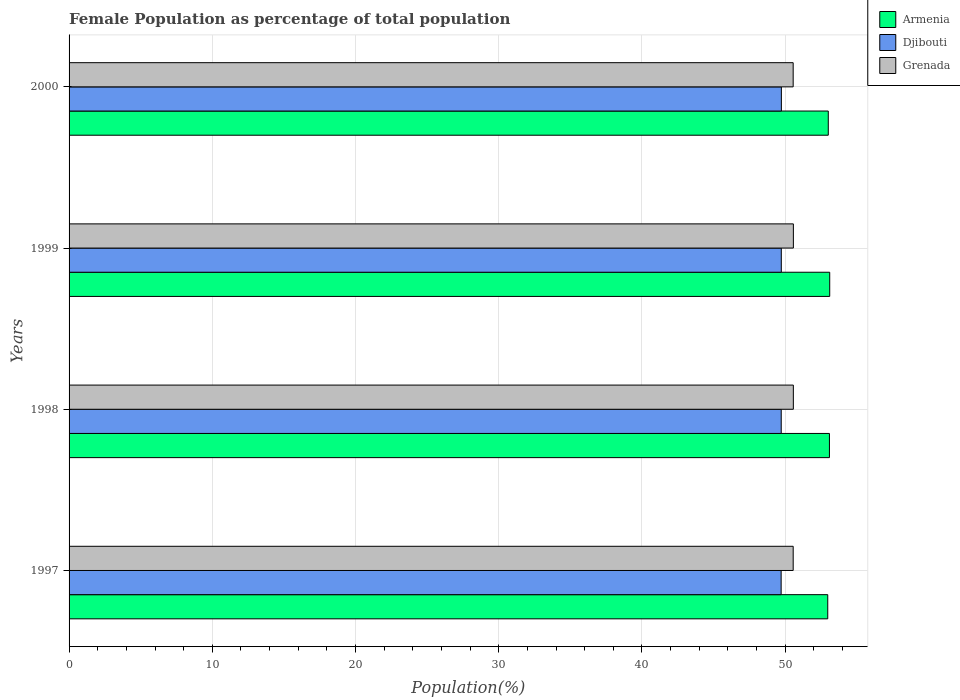How many groups of bars are there?
Offer a terse response. 4. Are the number of bars per tick equal to the number of legend labels?
Make the answer very short. Yes. Are the number of bars on each tick of the Y-axis equal?
Keep it short and to the point. Yes. How many bars are there on the 2nd tick from the top?
Make the answer very short. 3. What is the label of the 4th group of bars from the top?
Your answer should be very brief. 1997. What is the female population in in Grenada in 1997?
Offer a terse response. 50.56. Across all years, what is the maximum female population in in Armenia?
Provide a succinct answer. 53.11. Across all years, what is the minimum female population in in Grenada?
Your response must be concise. 50.56. In which year was the female population in in Grenada maximum?
Your answer should be very brief. 1999. What is the total female population in in Grenada in the graph?
Offer a very short reply. 202.26. What is the difference between the female population in in Djibouti in 1997 and that in 1999?
Provide a succinct answer. -0.01. What is the difference between the female population in in Grenada in 1998 and the female population in in Armenia in 1999?
Provide a succinct answer. -2.54. What is the average female population in in Djibouti per year?
Give a very brief answer. 49.73. In the year 1997, what is the difference between the female population in in Djibouti and female population in in Armenia?
Offer a very short reply. -3.25. In how many years, is the female population in in Armenia greater than 48 %?
Make the answer very short. 4. What is the ratio of the female population in in Djibouti in 1997 to that in 1998?
Give a very brief answer. 1. Is the difference between the female population in in Djibouti in 1997 and 2000 greater than the difference between the female population in in Armenia in 1997 and 2000?
Give a very brief answer. Yes. What is the difference between the highest and the second highest female population in in Grenada?
Make the answer very short. 0. What is the difference between the highest and the lowest female population in in Armenia?
Your response must be concise. 0.14. What does the 1st bar from the top in 2000 represents?
Provide a short and direct response. Grenada. What does the 1st bar from the bottom in 1997 represents?
Make the answer very short. Armenia. How many years are there in the graph?
Make the answer very short. 4. Are the values on the major ticks of X-axis written in scientific E-notation?
Provide a short and direct response. No. Does the graph contain grids?
Give a very brief answer. Yes. Where does the legend appear in the graph?
Offer a very short reply. Top right. How are the legend labels stacked?
Give a very brief answer. Vertical. What is the title of the graph?
Your answer should be compact. Female Population as percentage of total population. Does "El Salvador" appear as one of the legend labels in the graph?
Your response must be concise. No. What is the label or title of the X-axis?
Provide a short and direct response. Population(%). What is the Population(%) in Armenia in 1997?
Offer a very short reply. 52.97. What is the Population(%) in Djibouti in 1997?
Offer a terse response. 49.72. What is the Population(%) of Grenada in 1997?
Your answer should be compact. 50.56. What is the Population(%) in Armenia in 1998?
Give a very brief answer. 53.09. What is the Population(%) in Djibouti in 1998?
Your answer should be very brief. 49.72. What is the Population(%) in Grenada in 1998?
Give a very brief answer. 50.57. What is the Population(%) in Armenia in 1999?
Your answer should be very brief. 53.11. What is the Population(%) of Djibouti in 1999?
Keep it short and to the point. 49.73. What is the Population(%) of Grenada in 1999?
Give a very brief answer. 50.57. What is the Population(%) of Armenia in 2000?
Offer a very short reply. 53.01. What is the Population(%) of Djibouti in 2000?
Offer a very short reply. 49.73. What is the Population(%) of Grenada in 2000?
Offer a very short reply. 50.56. Across all years, what is the maximum Population(%) of Armenia?
Make the answer very short. 53.11. Across all years, what is the maximum Population(%) in Djibouti?
Your answer should be very brief. 49.73. Across all years, what is the maximum Population(%) of Grenada?
Ensure brevity in your answer.  50.57. Across all years, what is the minimum Population(%) of Armenia?
Keep it short and to the point. 52.97. Across all years, what is the minimum Population(%) of Djibouti?
Make the answer very short. 49.72. Across all years, what is the minimum Population(%) of Grenada?
Provide a succinct answer. 50.56. What is the total Population(%) of Armenia in the graph?
Offer a terse response. 212.18. What is the total Population(%) of Djibouti in the graph?
Offer a very short reply. 198.91. What is the total Population(%) of Grenada in the graph?
Keep it short and to the point. 202.26. What is the difference between the Population(%) in Armenia in 1997 and that in 1998?
Your response must be concise. -0.12. What is the difference between the Population(%) of Djibouti in 1997 and that in 1998?
Your answer should be compact. -0.01. What is the difference between the Population(%) of Grenada in 1997 and that in 1998?
Keep it short and to the point. -0.01. What is the difference between the Population(%) in Armenia in 1997 and that in 1999?
Ensure brevity in your answer.  -0.14. What is the difference between the Population(%) in Djibouti in 1997 and that in 1999?
Your answer should be compact. -0.01. What is the difference between the Population(%) of Grenada in 1997 and that in 1999?
Your answer should be very brief. -0.01. What is the difference between the Population(%) in Armenia in 1997 and that in 2000?
Give a very brief answer. -0.04. What is the difference between the Population(%) in Djibouti in 1997 and that in 2000?
Ensure brevity in your answer.  -0.02. What is the difference between the Population(%) of Grenada in 1997 and that in 2000?
Your answer should be very brief. 0. What is the difference between the Population(%) of Armenia in 1998 and that in 1999?
Your response must be concise. -0.02. What is the difference between the Population(%) of Djibouti in 1998 and that in 1999?
Provide a succinct answer. -0.01. What is the difference between the Population(%) of Grenada in 1998 and that in 1999?
Offer a very short reply. -0. What is the difference between the Population(%) of Armenia in 1998 and that in 2000?
Your response must be concise. 0.08. What is the difference between the Population(%) of Djibouti in 1998 and that in 2000?
Give a very brief answer. -0.01. What is the difference between the Population(%) in Grenada in 1998 and that in 2000?
Provide a short and direct response. 0.01. What is the difference between the Population(%) in Armenia in 1999 and that in 2000?
Make the answer very short. 0.1. What is the difference between the Population(%) in Djibouti in 1999 and that in 2000?
Offer a terse response. -0. What is the difference between the Population(%) of Grenada in 1999 and that in 2000?
Your answer should be very brief. 0.01. What is the difference between the Population(%) of Armenia in 1997 and the Population(%) of Djibouti in 1998?
Give a very brief answer. 3.25. What is the difference between the Population(%) in Armenia in 1997 and the Population(%) in Grenada in 1998?
Your response must be concise. 2.4. What is the difference between the Population(%) of Djibouti in 1997 and the Population(%) of Grenada in 1998?
Ensure brevity in your answer.  -0.85. What is the difference between the Population(%) in Armenia in 1997 and the Population(%) in Djibouti in 1999?
Your response must be concise. 3.24. What is the difference between the Population(%) of Armenia in 1997 and the Population(%) of Grenada in 1999?
Provide a succinct answer. 2.4. What is the difference between the Population(%) of Djibouti in 1997 and the Population(%) of Grenada in 1999?
Your answer should be compact. -0.85. What is the difference between the Population(%) in Armenia in 1997 and the Population(%) in Djibouti in 2000?
Provide a short and direct response. 3.24. What is the difference between the Population(%) in Armenia in 1997 and the Population(%) in Grenada in 2000?
Provide a succinct answer. 2.41. What is the difference between the Population(%) in Djibouti in 1997 and the Population(%) in Grenada in 2000?
Give a very brief answer. -0.84. What is the difference between the Population(%) of Armenia in 1998 and the Population(%) of Djibouti in 1999?
Make the answer very short. 3.36. What is the difference between the Population(%) of Armenia in 1998 and the Population(%) of Grenada in 1999?
Provide a short and direct response. 2.52. What is the difference between the Population(%) in Djibouti in 1998 and the Population(%) in Grenada in 1999?
Offer a very short reply. -0.85. What is the difference between the Population(%) of Armenia in 1998 and the Population(%) of Djibouti in 2000?
Offer a very short reply. 3.36. What is the difference between the Population(%) of Armenia in 1998 and the Population(%) of Grenada in 2000?
Provide a succinct answer. 2.53. What is the difference between the Population(%) of Djibouti in 1998 and the Population(%) of Grenada in 2000?
Your answer should be very brief. -0.83. What is the difference between the Population(%) of Armenia in 1999 and the Population(%) of Djibouti in 2000?
Your answer should be compact. 3.38. What is the difference between the Population(%) of Armenia in 1999 and the Population(%) of Grenada in 2000?
Offer a terse response. 2.55. What is the difference between the Population(%) in Djibouti in 1999 and the Population(%) in Grenada in 2000?
Your response must be concise. -0.83. What is the average Population(%) in Armenia per year?
Make the answer very short. 53.05. What is the average Population(%) in Djibouti per year?
Make the answer very short. 49.73. What is the average Population(%) in Grenada per year?
Your response must be concise. 50.56. In the year 1997, what is the difference between the Population(%) in Armenia and Population(%) in Djibouti?
Offer a very short reply. 3.25. In the year 1997, what is the difference between the Population(%) in Armenia and Population(%) in Grenada?
Provide a short and direct response. 2.41. In the year 1997, what is the difference between the Population(%) in Djibouti and Population(%) in Grenada?
Your response must be concise. -0.84. In the year 1998, what is the difference between the Population(%) in Armenia and Population(%) in Djibouti?
Give a very brief answer. 3.37. In the year 1998, what is the difference between the Population(%) of Armenia and Population(%) of Grenada?
Provide a short and direct response. 2.52. In the year 1998, what is the difference between the Population(%) of Djibouti and Population(%) of Grenada?
Ensure brevity in your answer.  -0.85. In the year 1999, what is the difference between the Population(%) in Armenia and Population(%) in Djibouti?
Your answer should be compact. 3.38. In the year 1999, what is the difference between the Population(%) in Armenia and Population(%) in Grenada?
Provide a succinct answer. 2.54. In the year 1999, what is the difference between the Population(%) in Djibouti and Population(%) in Grenada?
Offer a terse response. -0.84. In the year 2000, what is the difference between the Population(%) of Armenia and Population(%) of Djibouti?
Provide a short and direct response. 3.28. In the year 2000, what is the difference between the Population(%) in Armenia and Population(%) in Grenada?
Provide a succinct answer. 2.45. In the year 2000, what is the difference between the Population(%) of Djibouti and Population(%) of Grenada?
Make the answer very short. -0.82. What is the ratio of the Population(%) of Armenia in 1997 to that in 1998?
Keep it short and to the point. 1. What is the ratio of the Population(%) of Grenada in 1997 to that in 1998?
Ensure brevity in your answer.  1. What is the ratio of the Population(%) in Armenia in 1997 to that in 1999?
Your answer should be compact. 1. What is the ratio of the Population(%) in Armenia in 1997 to that in 2000?
Provide a succinct answer. 1. What is the ratio of the Population(%) in Djibouti in 1998 to that in 1999?
Offer a very short reply. 1. What is the ratio of the Population(%) in Armenia in 1998 to that in 2000?
Give a very brief answer. 1. What is the ratio of the Population(%) of Grenada in 1998 to that in 2000?
Give a very brief answer. 1. What is the ratio of the Population(%) in Djibouti in 1999 to that in 2000?
Provide a succinct answer. 1. What is the difference between the highest and the second highest Population(%) in Armenia?
Provide a succinct answer. 0.02. What is the difference between the highest and the second highest Population(%) of Djibouti?
Your response must be concise. 0. What is the difference between the highest and the second highest Population(%) in Grenada?
Give a very brief answer. 0. What is the difference between the highest and the lowest Population(%) in Armenia?
Provide a short and direct response. 0.14. What is the difference between the highest and the lowest Population(%) of Djibouti?
Your response must be concise. 0.02. What is the difference between the highest and the lowest Population(%) in Grenada?
Provide a succinct answer. 0.01. 